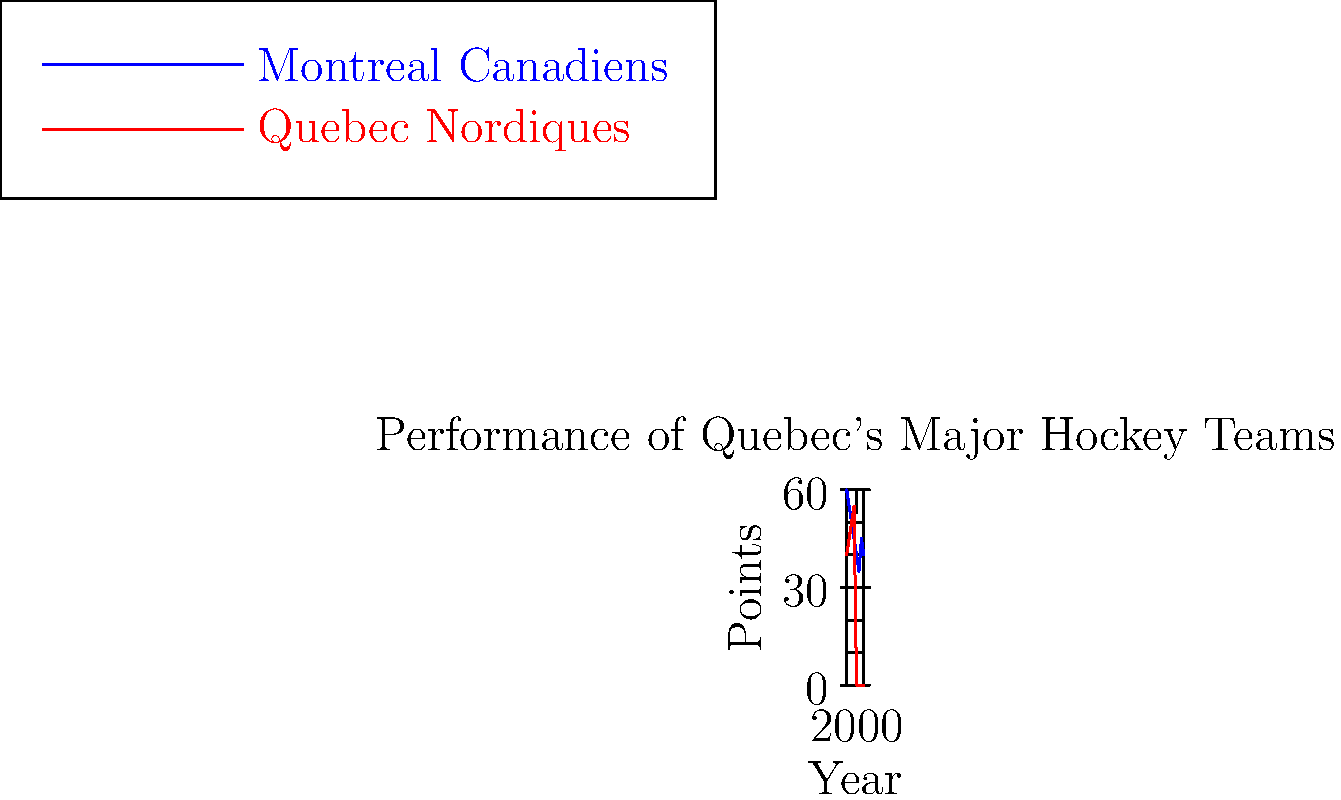Based on the line graph showing the historical performance of Quebec's major hockey teams, what significant event can be inferred to have occurred around 1995 regarding the Quebec Nordiques? To answer this question, we need to analyze the line graph carefully:

1. The graph shows two lines representing the performance of the Montreal Canadiens (blue) and Quebec Nordiques (red) from 1980 to 2015.

2. The Quebec Nordiques' line suddenly drops to zero points after 1995 and remains at zero for the rest of the timeline.

3. This abrupt end to the Nordiques' data line suggests a major change in the team's status.

4. In the context of professional sports, a team's performance suddenly dropping to zero and remaining there typically indicates that the team ceased to exist or relocated.

5. Given the historical context of Quebec's hockey teams, this graph is likely showing the relocation of the Quebec Nordiques.

6. In reality, the Quebec Nordiques were indeed relocated to Denver, Colorado, in 1995, becoming the Colorado Avalanche.

Therefore, the significant event that can be inferred from the graph is the relocation or dissolution of the Quebec Nordiques team around 1995.
Answer: Relocation of the Quebec Nordiques 